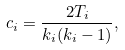<formula> <loc_0><loc_0><loc_500><loc_500>c _ { i } = \frac { 2 T _ { i } } { k _ { i } ( k _ { i } - 1 ) } ,</formula> 